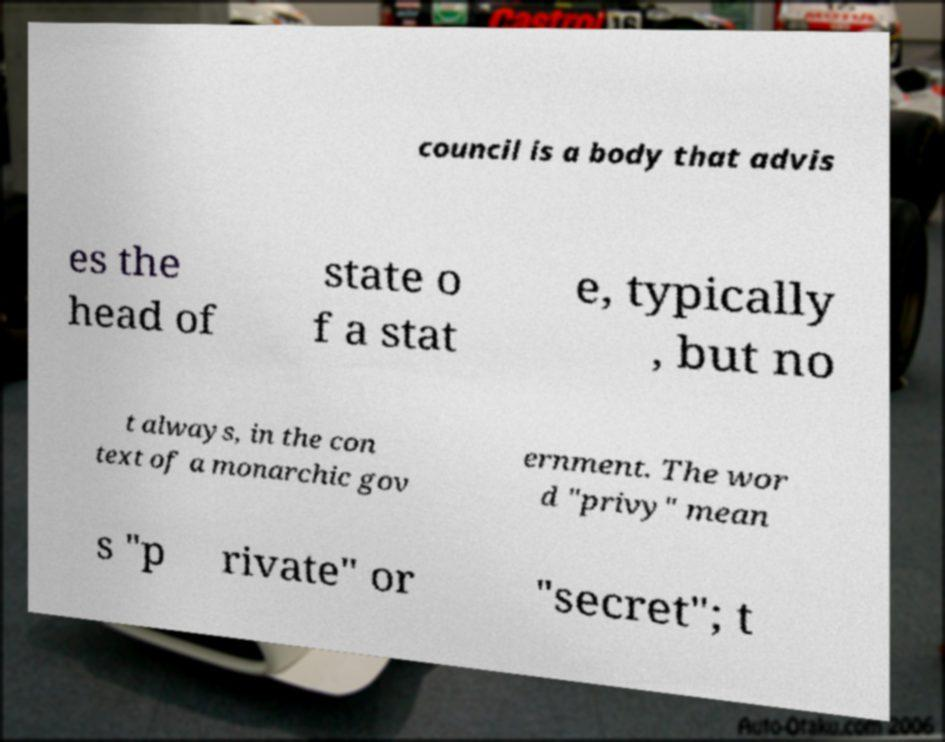What messages or text are displayed in this image? I need them in a readable, typed format. council is a body that advis es the head of state o f a stat e, typically , but no t always, in the con text of a monarchic gov ernment. The wor d "privy" mean s "p rivate" or "secret"; t 